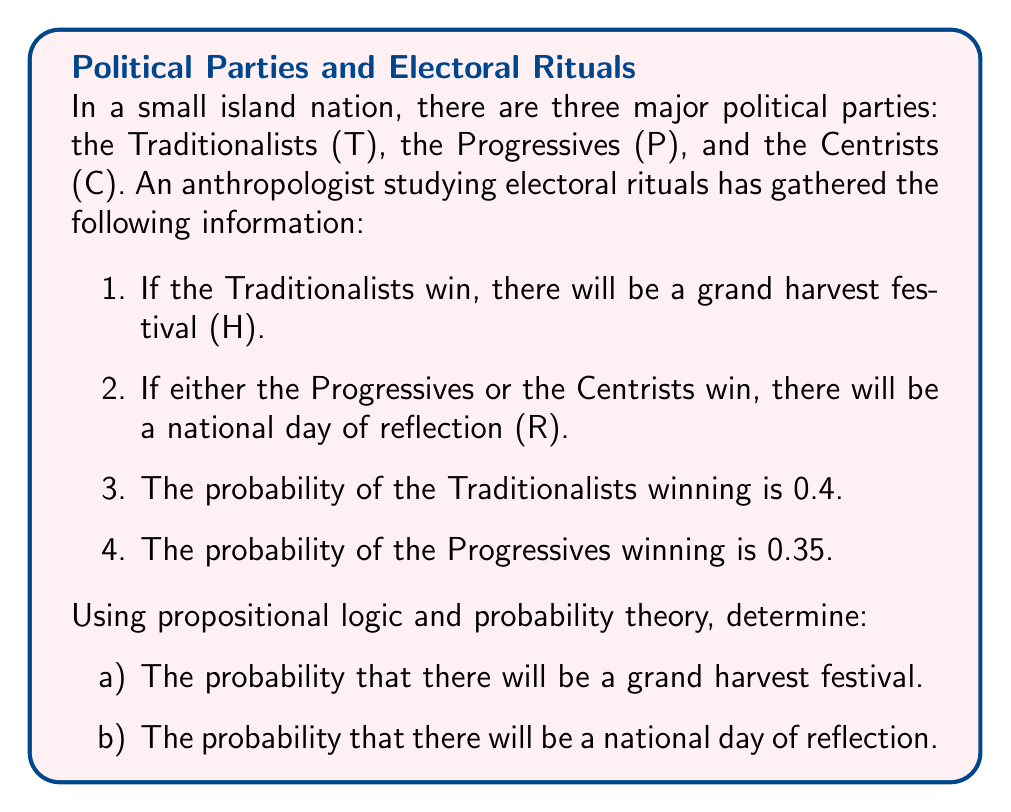What is the answer to this math problem? Let's approach this step-by-step using propositional logic and probability theory:

1) First, let's define our propositions:
   T: Traditionalists win
   P: Progressives win
   C: Centrists win
   H: Grand harvest festival occurs
   R: National day of reflection occurs

2) From the given information, we can write:
   T → H (If T, then H)
   P ∨ C → R (If P or C, then R)

3) We're given the probabilities:
   P(T) = 0.4
   P(P) = 0.35

4) Since only one party can win, we know:
   P(T) + P(P) + P(C) = 1
   0.4 + 0.35 + P(C) = 1
   P(C) = 0.25

5) Now, let's solve each part:

   a) Probability of a grand harvest festival:
      H occurs if and only if T wins, so:
      P(H) = P(T) = 0.4

   b) Probability of a national day of reflection:
      R occurs if either P or C wins. In propositional logic, this is equivalent to ¬T (not T).
      P(R) = P(P ∨ C) = P(¬T) = 1 - P(T) = 1 - 0.4 = 0.6

      We can verify this:
      P(P) + P(C) = 0.35 + 0.25 = 0.6

Thus, we have calculated the probabilities of both electoral outcomes using propositional logic and probability theory.
Answer: a) P(H) = 0.4
b) P(R) = 0.6 